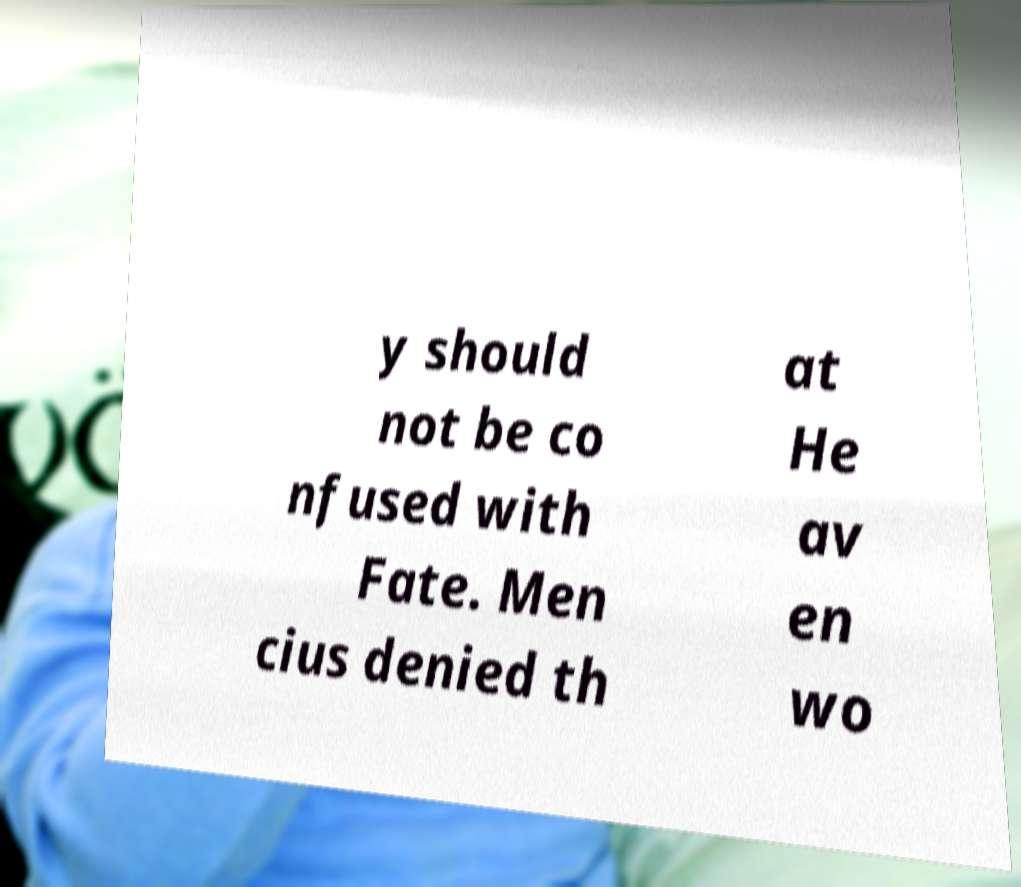What messages or text are displayed in this image? I need them in a readable, typed format. y should not be co nfused with Fate. Men cius denied th at He av en wo 